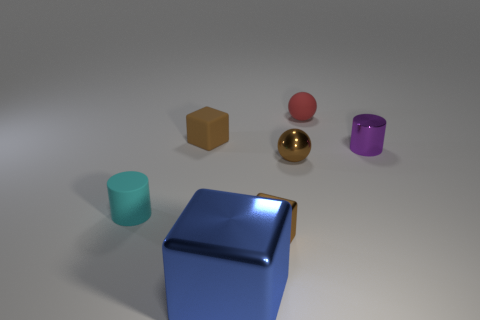What color is the matte object that is the same shape as the large blue metallic object?
Your response must be concise. Brown. Are there more tiny cyan rubber things to the right of the big object than red matte cylinders?
Make the answer very short. No. Is the shape of the large blue metal object the same as the small brown object that is to the left of the blue thing?
Provide a succinct answer. Yes. Are there any other things that have the same size as the brown rubber block?
Your answer should be compact. Yes. The cyan object that is the same shape as the purple thing is what size?
Offer a very short reply. Small. Are there more metal cubes than tiny matte spheres?
Give a very brief answer. Yes. Is the shape of the small purple thing the same as the brown matte thing?
Make the answer very short. No. What material is the tiny cylinder on the right side of the tiny cube that is to the right of the large blue metal cube?
Give a very brief answer. Metal. There is another cube that is the same color as the small metallic cube; what is it made of?
Make the answer very short. Rubber. Is the size of the blue metallic object the same as the red thing?
Make the answer very short. No. 